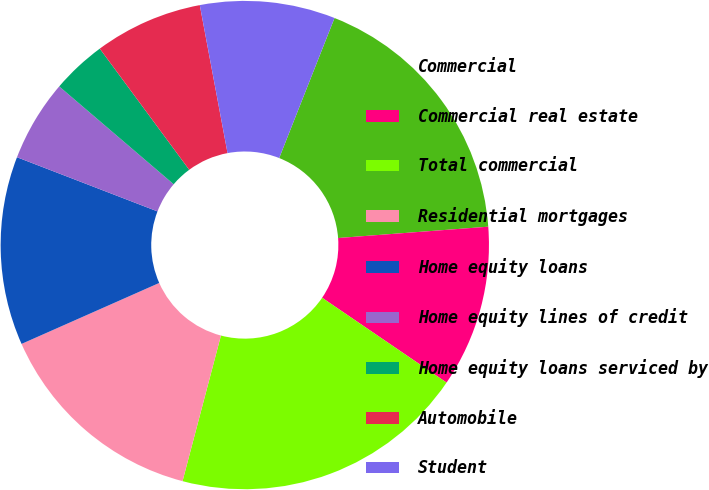<chart> <loc_0><loc_0><loc_500><loc_500><pie_chart><fcel>Commercial<fcel>Commercial real estate<fcel>Total commercial<fcel>Residential mortgages<fcel>Home equity loans<fcel>Home equity lines of credit<fcel>Home equity loans serviced by<fcel>Automobile<fcel>Student<nl><fcel>17.81%<fcel>10.72%<fcel>19.58%<fcel>14.26%<fcel>12.49%<fcel>5.4%<fcel>3.62%<fcel>7.17%<fcel>8.94%<nl></chart> 